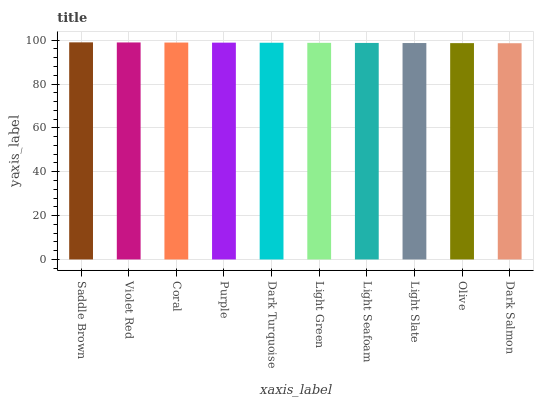Is Dark Salmon the minimum?
Answer yes or no. Yes. Is Saddle Brown the maximum?
Answer yes or no. Yes. Is Violet Red the minimum?
Answer yes or no. No. Is Violet Red the maximum?
Answer yes or no. No. Is Saddle Brown greater than Violet Red?
Answer yes or no. Yes. Is Violet Red less than Saddle Brown?
Answer yes or no. Yes. Is Violet Red greater than Saddle Brown?
Answer yes or no. No. Is Saddle Brown less than Violet Red?
Answer yes or no. No. Is Dark Turquoise the high median?
Answer yes or no. Yes. Is Light Green the low median?
Answer yes or no. Yes. Is Coral the high median?
Answer yes or no. No. Is Dark Salmon the low median?
Answer yes or no. No. 